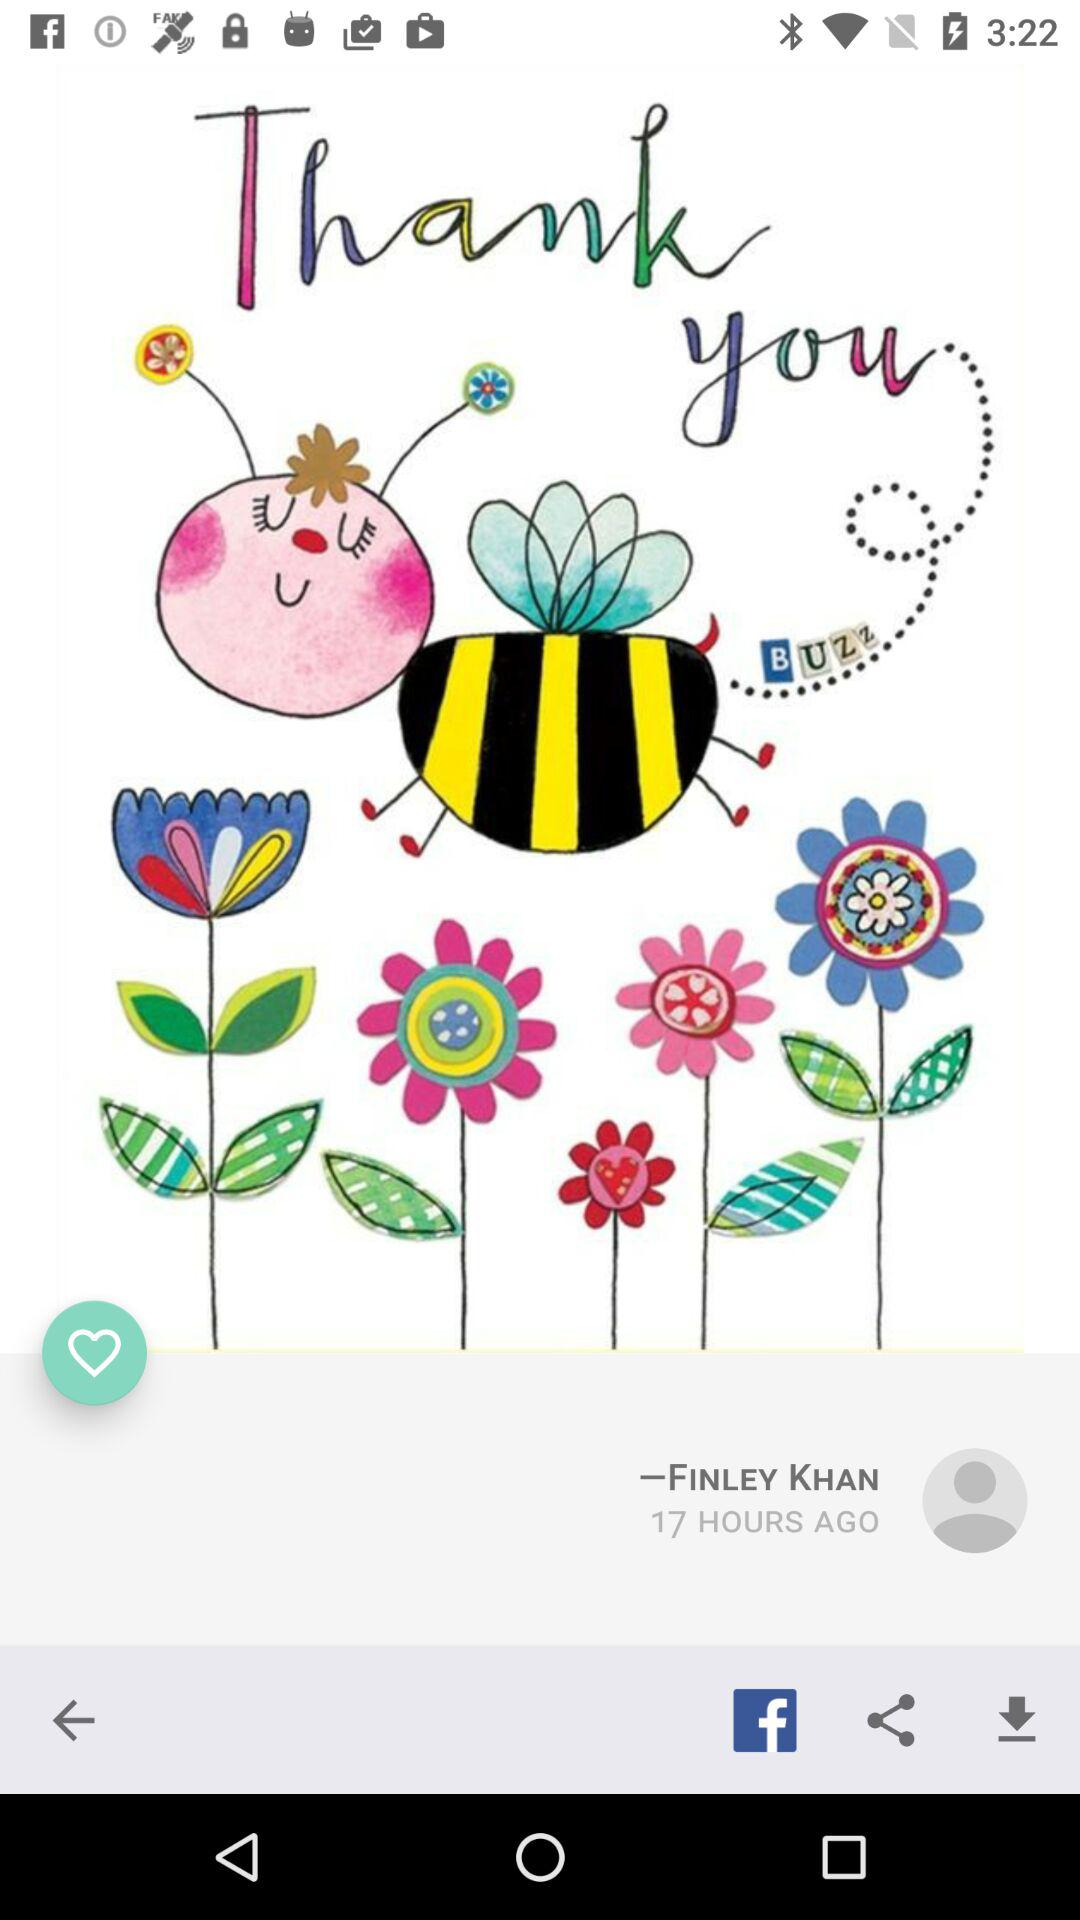What's the user profile name? The user profile name is Finley Khan. 